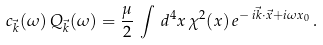<formula> <loc_0><loc_0><loc_500><loc_500>c _ { \vec { k } } ( \omega ) \, Q _ { \vec { k } } ( \omega ) = \frac { \mu } { 2 } \, \int \, d ^ { 4 } x \, \chi ^ { 2 } ( x ) \, e ^ { - \, i \vec { k } \cdot \vec { x } + i \omega x _ { 0 } } \, .</formula> 